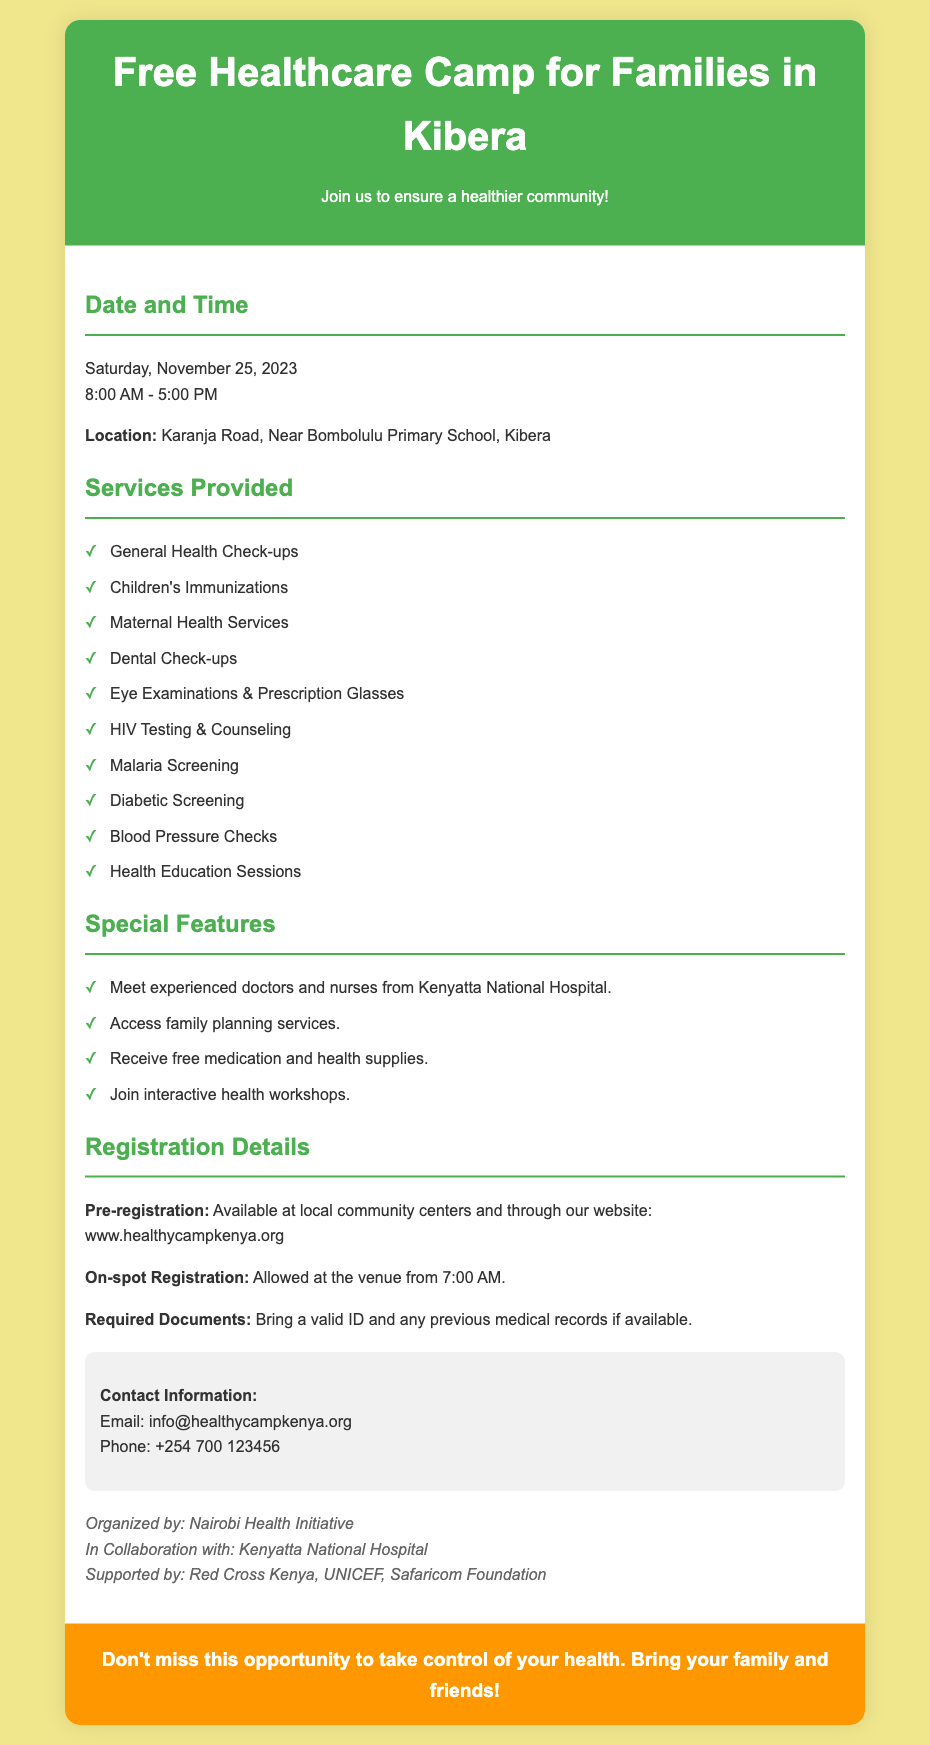What is the date of the healthcare camp? The date is specified in the document as Saturday, November 25, 2023.
Answer: Saturday, November 25, 2023 What time does the camp start? The camp starts at 8:00 AM as stated in the document.
Answer: 8:00 AM Where is the location of the camp? The location is detailed in the document as Karanja Road, Near Bombolulu Primary School, Kibera.
Answer: Karanja Road, Near Bombolulu Primary School, Kibera What service is provided for children? The document lists Children's Immunizations as a service provided.
Answer: Children's Immunizations What is required for on-spot registration? The document mentions a valid ID and previous medical records as required documents.
Answer: Valid ID and previous medical records How many hours does the camp run? The document states that the camp runs from 8 AM to 5 PM, providing a total of 9 hours.
Answer: 9 hours Who are the organizers of the event? The document identifies Nairobi Health Initiative as the organizer.
Answer: Nairobi Health Initiative What is available for pre-registration? Local community centers and the website are mentioned for pre-registration in the document.
Answer: Local community centers and website How can I contact for more information? The contact information provided includes an email and a phone number for inquiries.
Answer: info@healthycampkenya.org, +254 700 123456 